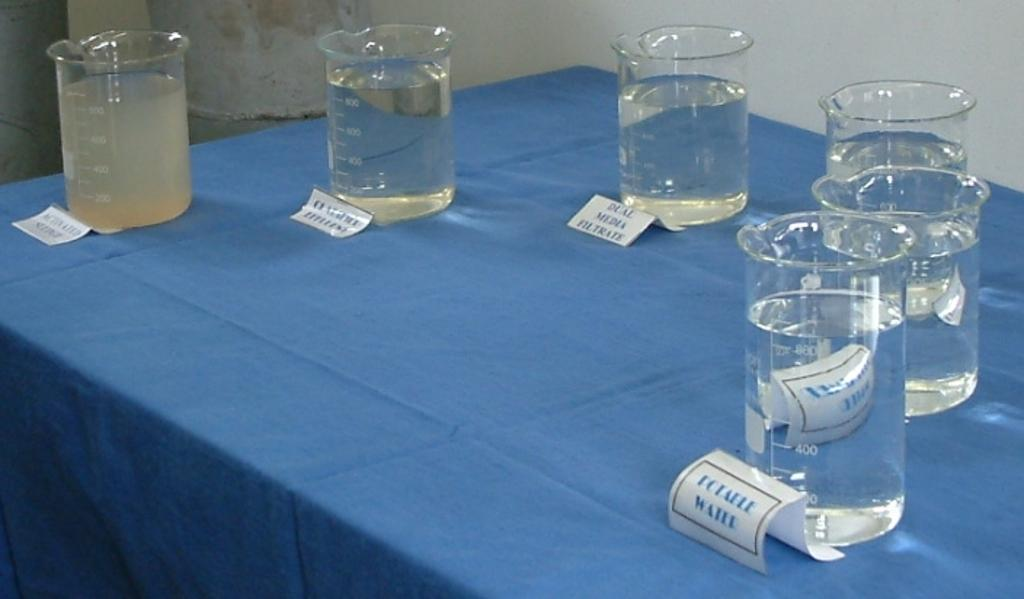<image>
Relay a brief, clear account of the picture shown. A table contains six beakers filled with water that are identified with such labels as DUAL MEDIA FILTRATE and POTABLE WATER. 